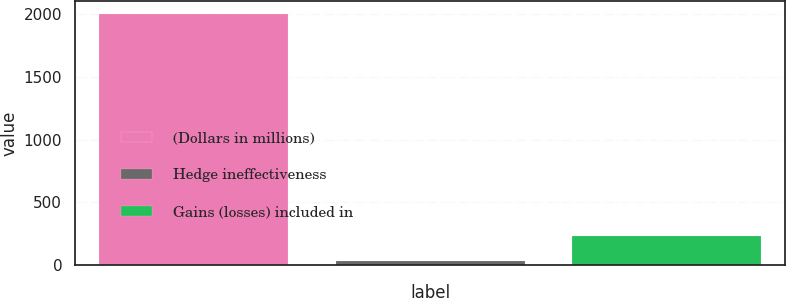Convert chart to OTSL. <chart><loc_0><loc_0><loc_500><loc_500><bar_chart><fcel>(Dollars in millions)<fcel>Hedge ineffectiveness<fcel>Gains (losses) included in<nl><fcel>2005<fcel>31<fcel>228.4<nl></chart> 